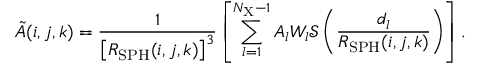Convert formula to latex. <formula><loc_0><loc_0><loc_500><loc_500>\tilde { A } ( i , j , k ) = \frac { 1 } { \left [ R _ { S P H } ( i , j , k ) \right ] ^ { 3 } } \left [ \sum _ { l = 1 } ^ { N _ { X } - 1 } A _ { l } W _ { l } \mathcal { S } \left ( \frac { d _ { l } } { R _ { S P H } ( i , j , k ) } \right ) \right ] .</formula> 